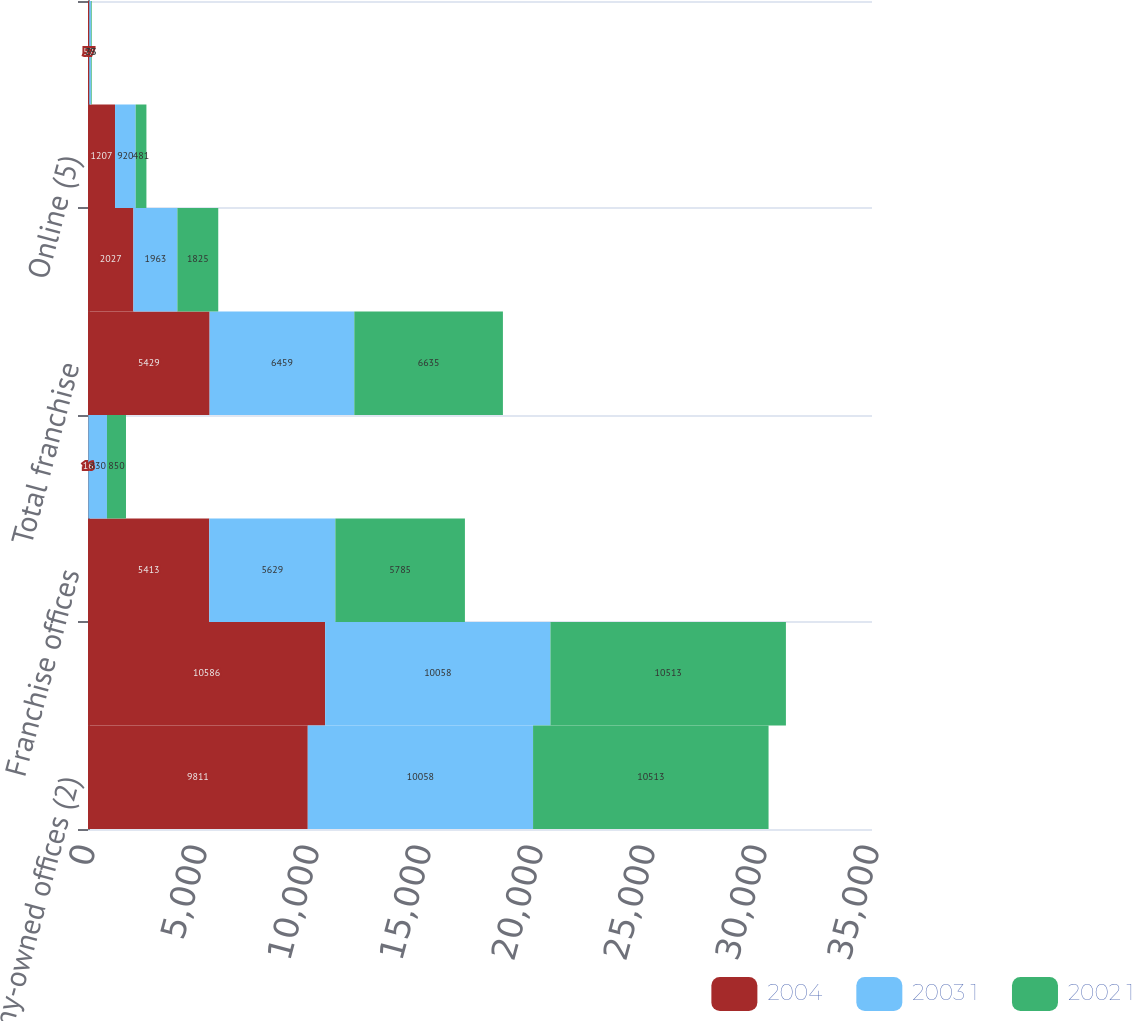<chart> <loc_0><loc_0><loc_500><loc_500><stacked_bar_chart><ecel><fcel>Company-owned offices (2)<fcel>Total company-owned<fcel>Franchise offices<fcel>Former major franchise<fcel>Total franchise<fcel>Software (4)<fcel>Online (5)<fcel>Online<nl><fcel>2004<fcel>9811<fcel>10586<fcel>5413<fcel>16<fcel>5429<fcel>2027<fcel>1207<fcel>57<nl><fcel>2003 1<fcel>10058<fcel>10058<fcel>5629<fcel>830<fcel>6459<fcel>1963<fcel>920<fcel>75<nl><fcel>2002 1<fcel>10513<fcel>10513<fcel>5785<fcel>850<fcel>6635<fcel>1825<fcel>481<fcel>33<nl></chart> 